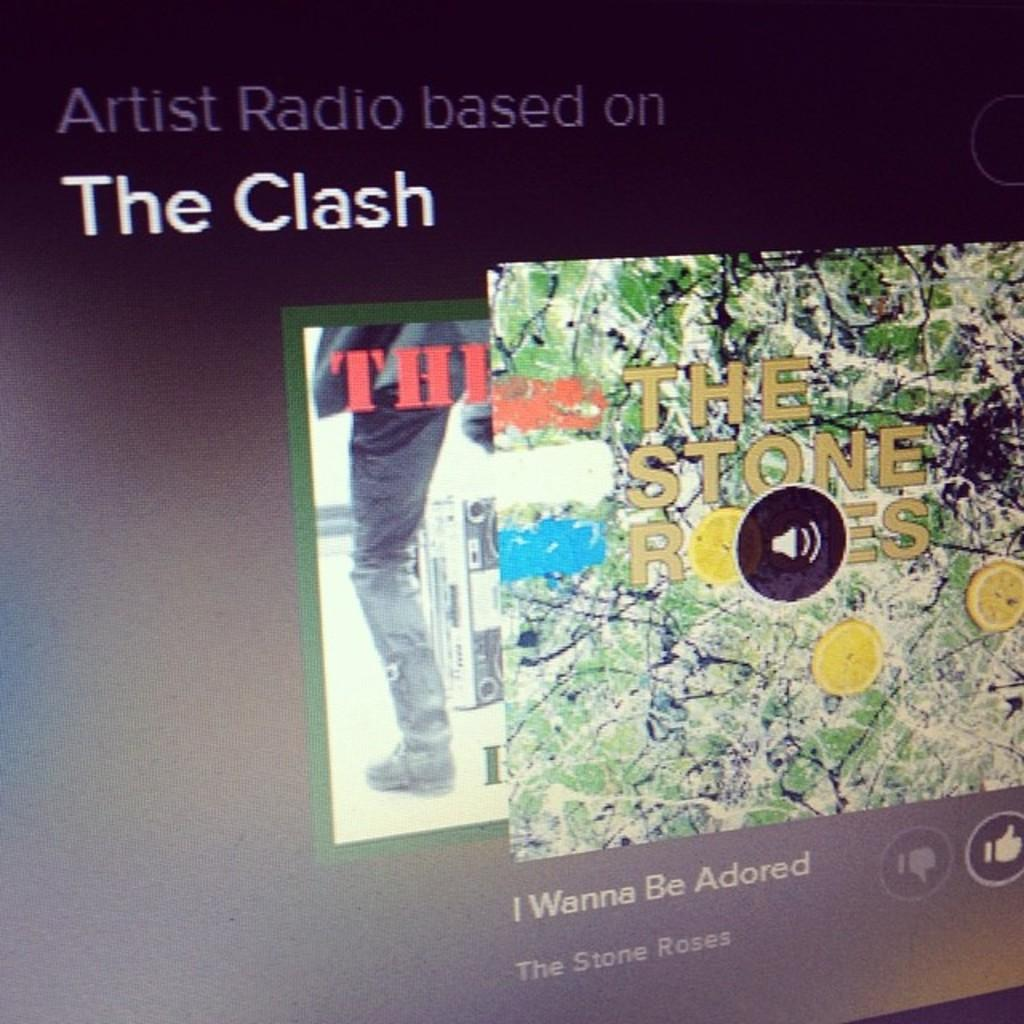<image>
Give a short and clear explanation of the subsequent image. A radio station based on The Clash is playing a song by The Stone Roses. 